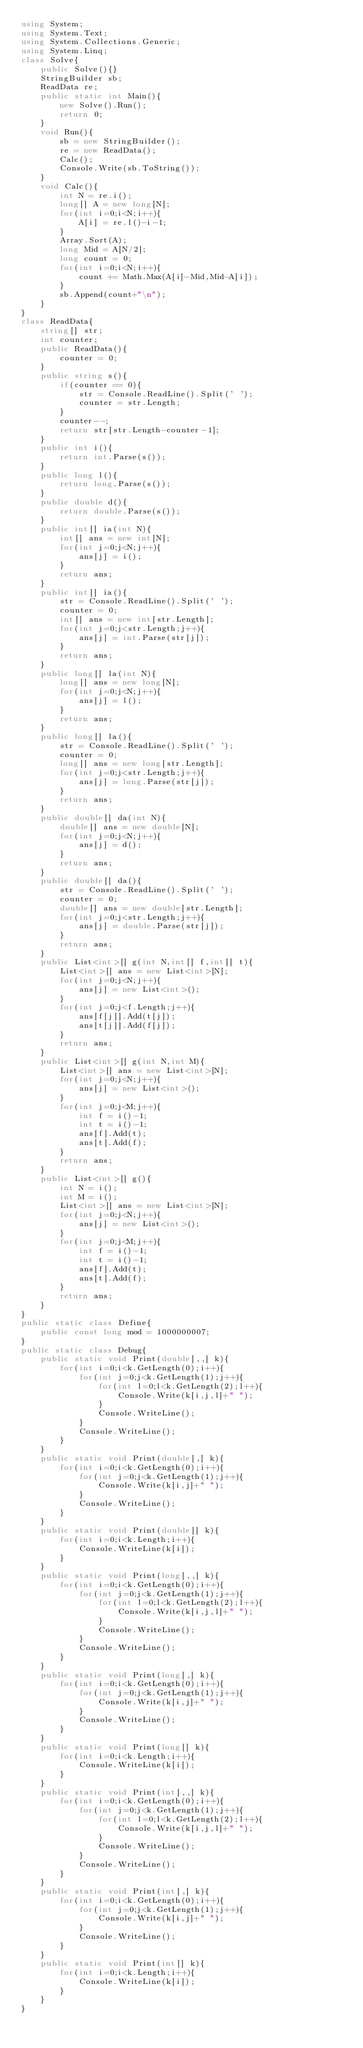Convert code to text. <code><loc_0><loc_0><loc_500><loc_500><_C#_>using System;
using System.Text;
using System.Collections.Generic;
using System.Linq;
class Solve{
    public Solve(){}
    StringBuilder sb;
    ReadData re;
    public static int Main(){
        new Solve().Run();
        return 0;
    }
    void Run(){
        sb = new StringBuilder();
        re = new ReadData();
        Calc();
        Console.Write(sb.ToString());
    }
    void Calc(){
        int N = re.i();
        long[] A = new long[N];
        for(int i=0;i<N;i++){
            A[i] = re.l()-i-1;
        }
        Array.Sort(A);
        long Mid = A[N/2];
        long count = 0;
        for(int i=0;i<N;i++){
            count += Math.Max(A[i]-Mid,Mid-A[i]);
        }
        sb.Append(count+"\n");
    }
}
class ReadData{
    string[] str;
    int counter;
    public ReadData(){
        counter = 0;
    }
    public string s(){
        if(counter == 0){
            str = Console.ReadLine().Split(' ');
            counter = str.Length;
        }
        counter--;
        return str[str.Length-counter-1];
    }
    public int i(){
        return int.Parse(s());
    }
    public long l(){
        return long.Parse(s());
    }
    public double d(){
        return double.Parse(s());
    }
    public int[] ia(int N){
        int[] ans = new int[N];
        for(int j=0;j<N;j++){
            ans[j] = i();
        }
        return ans;
    }
    public int[] ia(){
        str = Console.ReadLine().Split(' ');
        counter = 0;
        int[] ans = new int[str.Length];
        for(int j=0;j<str.Length;j++){
            ans[j] = int.Parse(str[j]);
        }
        return ans;
    }
    public long[] la(int N){
        long[] ans = new long[N];
        for(int j=0;j<N;j++){
            ans[j] = l();
        }
        return ans;
    }
    public long[] la(){
        str = Console.ReadLine().Split(' ');
        counter = 0;
        long[] ans = new long[str.Length];
        for(int j=0;j<str.Length;j++){
            ans[j] = long.Parse(str[j]);
        }
        return ans;
    }
    public double[] da(int N){
        double[] ans = new double[N];
        for(int j=0;j<N;j++){
            ans[j] = d();
        }
        return ans;
    }
    public double[] da(){
        str = Console.ReadLine().Split(' ');
        counter = 0;
        double[] ans = new double[str.Length];
        for(int j=0;j<str.Length;j++){
            ans[j] = double.Parse(str[j]);
        }
        return ans;
    }
    public List<int>[] g(int N,int[] f,int[] t){
        List<int>[] ans = new List<int>[N];
        for(int j=0;j<N;j++){
            ans[j] = new List<int>();
        }
        for(int j=0;j<f.Length;j++){
            ans[f[j]].Add(t[j]);
            ans[t[j]].Add(f[j]);
        }
        return ans;
    }
    public List<int>[] g(int N,int M){
        List<int>[] ans = new List<int>[N];
        for(int j=0;j<N;j++){
            ans[j] = new List<int>();
        }
        for(int j=0;j<M;j++){
            int f = i()-1;
            int t = i()-1;
            ans[f].Add(t);
            ans[t].Add(f);
        }
        return ans;
    }
    public List<int>[] g(){
        int N = i();
        int M = i();
        List<int>[] ans = new List<int>[N];
        for(int j=0;j<N;j++){
            ans[j] = new List<int>();
        }
        for(int j=0;j<M;j++){
            int f = i()-1;
            int t = i()-1;
            ans[f].Add(t);
            ans[t].Add(f);
        }
        return ans;
    }
}
public static class Define{
    public const long mod = 1000000007;
}
public static class Debug{
    public static void Print(double[,,] k){
        for(int i=0;i<k.GetLength(0);i++){
            for(int j=0;j<k.GetLength(1);j++){
                for(int l=0;l<k.GetLength(2);l++){
                    Console.Write(k[i,j,l]+" ");
                }
                Console.WriteLine();
            }
            Console.WriteLine();
        }
    }
    public static void Print(double[,] k){
        for(int i=0;i<k.GetLength(0);i++){
            for(int j=0;j<k.GetLength(1);j++){
                Console.Write(k[i,j]+" ");
            }
            Console.WriteLine();
        }
    }
    public static void Print(double[] k){
        for(int i=0;i<k.Length;i++){
            Console.WriteLine(k[i]);
        }
    }
    public static void Print(long[,,] k){
        for(int i=0;i<k.GetLength(0);i++){
            for(int j=0;j<k.GetLength(1);j++){
                for(int l=0;l<k.GetLength(2);l++){
                    Console.Write(k[i,j,l]+" ");
                }
                Console.WriteLine();
            }
            Console.WriteLine();
        }
    }
    public static void Print(long[,] k){
        for(int i=0;i<k.GetLength(0);i++){
            for(int j=0;j<k.GetLength(1);j++){
                Console.Write(k[i,j]+" ");
            }
            Console.WriteLine();
        }
    }
    public static void Print(long[] k){
        for(int i=0;i<k.Length;i++){
            Console.WriteLine(k[i]);
        }
    }
    public static void Print(int[,,] k){
        for(int i=0;i<k.GetLength(0);i++){
            for(int j=0;j<k.GetLength(1);j++){
                for(int l=0;l<k.GetLength(2);l++){
                    Console.Write(k[i,j,l]+" ");
                }
                Console.WriteLine();
            }
            Console.WriteLine();
        }
    }
    public static void Print(int[,] k){
        for(int i=0;i<k.GetLength(0);i++){
            for(int j=0;j<k.GetLength(1);j++){
                Console.Write(k[i,j]+" ");
            }
            Console.WriteLine();
        }
    }
    public static void Print(int[] k){
        for(int i=0;i<k.Length;i++){
            Console.WriteLine(k[i]);
        }
    }
}
</code> 